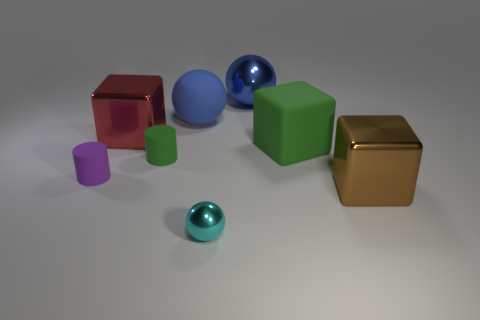Add 2 small purple rubber cylinders. How many objects exist? 10 Subtract all cylinders. How many objects are left? 6 Add 2 tiny purple cylinders. How many tiny purple cylinders are left? 3 Add 2 rubber cubes. How many rubber cubes exist? 3 Subtract 0 brown cylinders. How many objects are left? 8 Subtract all purple objects. Subtract all purple rubber cylinders. How many objects are left? 6 